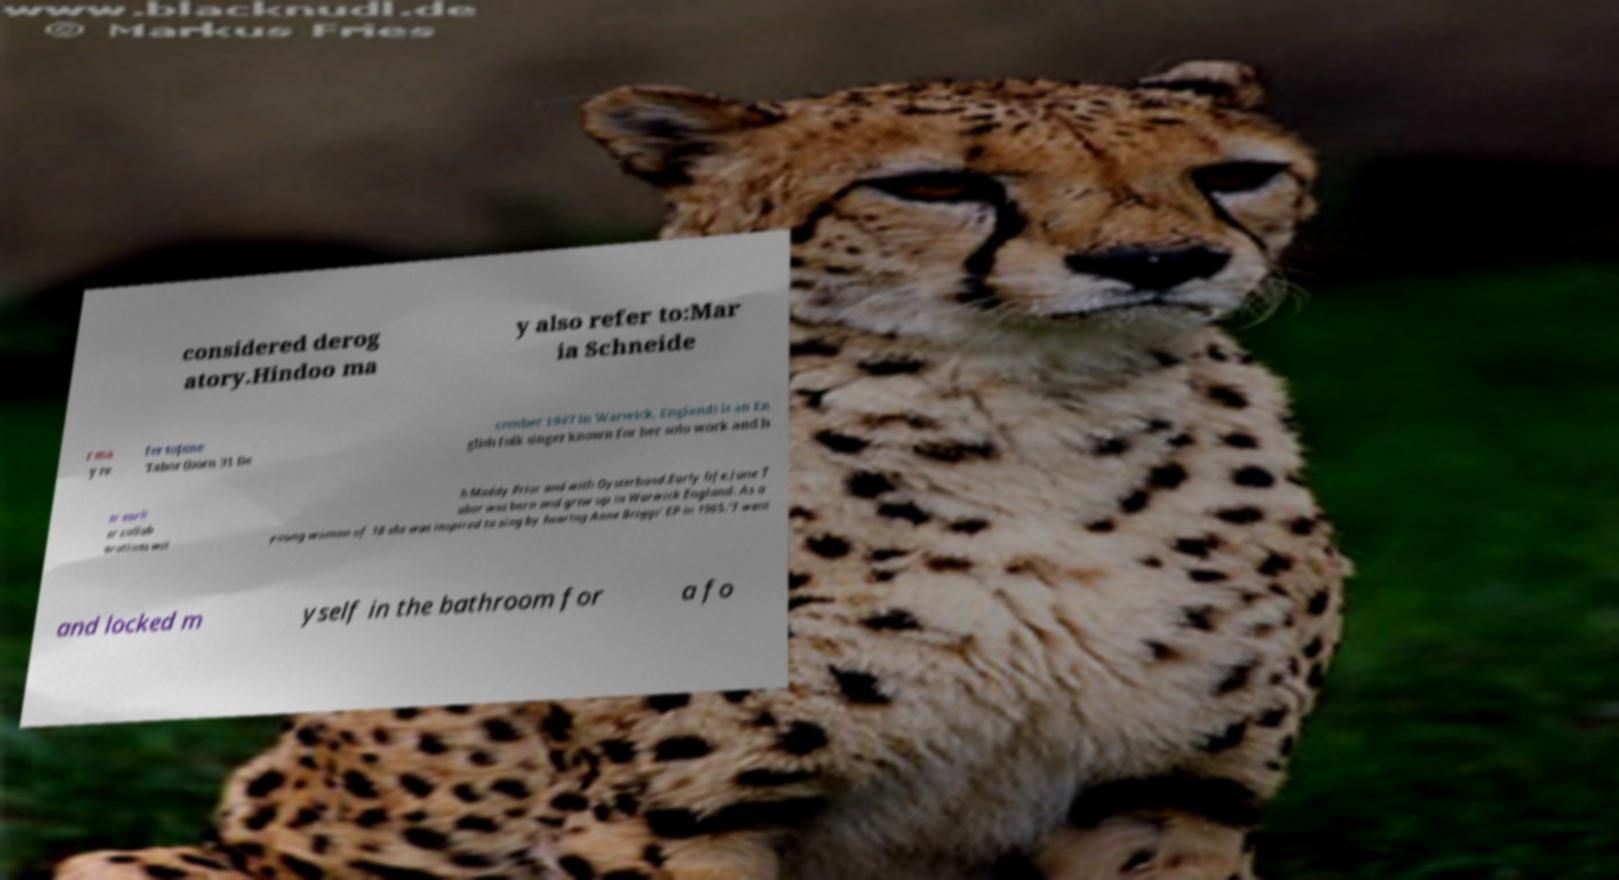Can you read and provide the text displayed in the image?This photo seems to have some interesting text. Can you extract and type it out for me? considered derog atory.Hindoo ma y also refer to:Mar ia Schneide r ma y re fer toJune Tabor (born 31 De cember 1947 in Warwick, England) is an En glish folk singer known for her solo work and h er earli er collab orations wit h Maddy Prior and with Oysterband.Early life.June T abor was born and grew up in Warwick England. As a young woman of 18 she was inspired to sing by hearing Anne Briggs' EP in 1965."I went and locked m yself in the bathroom for a fo 